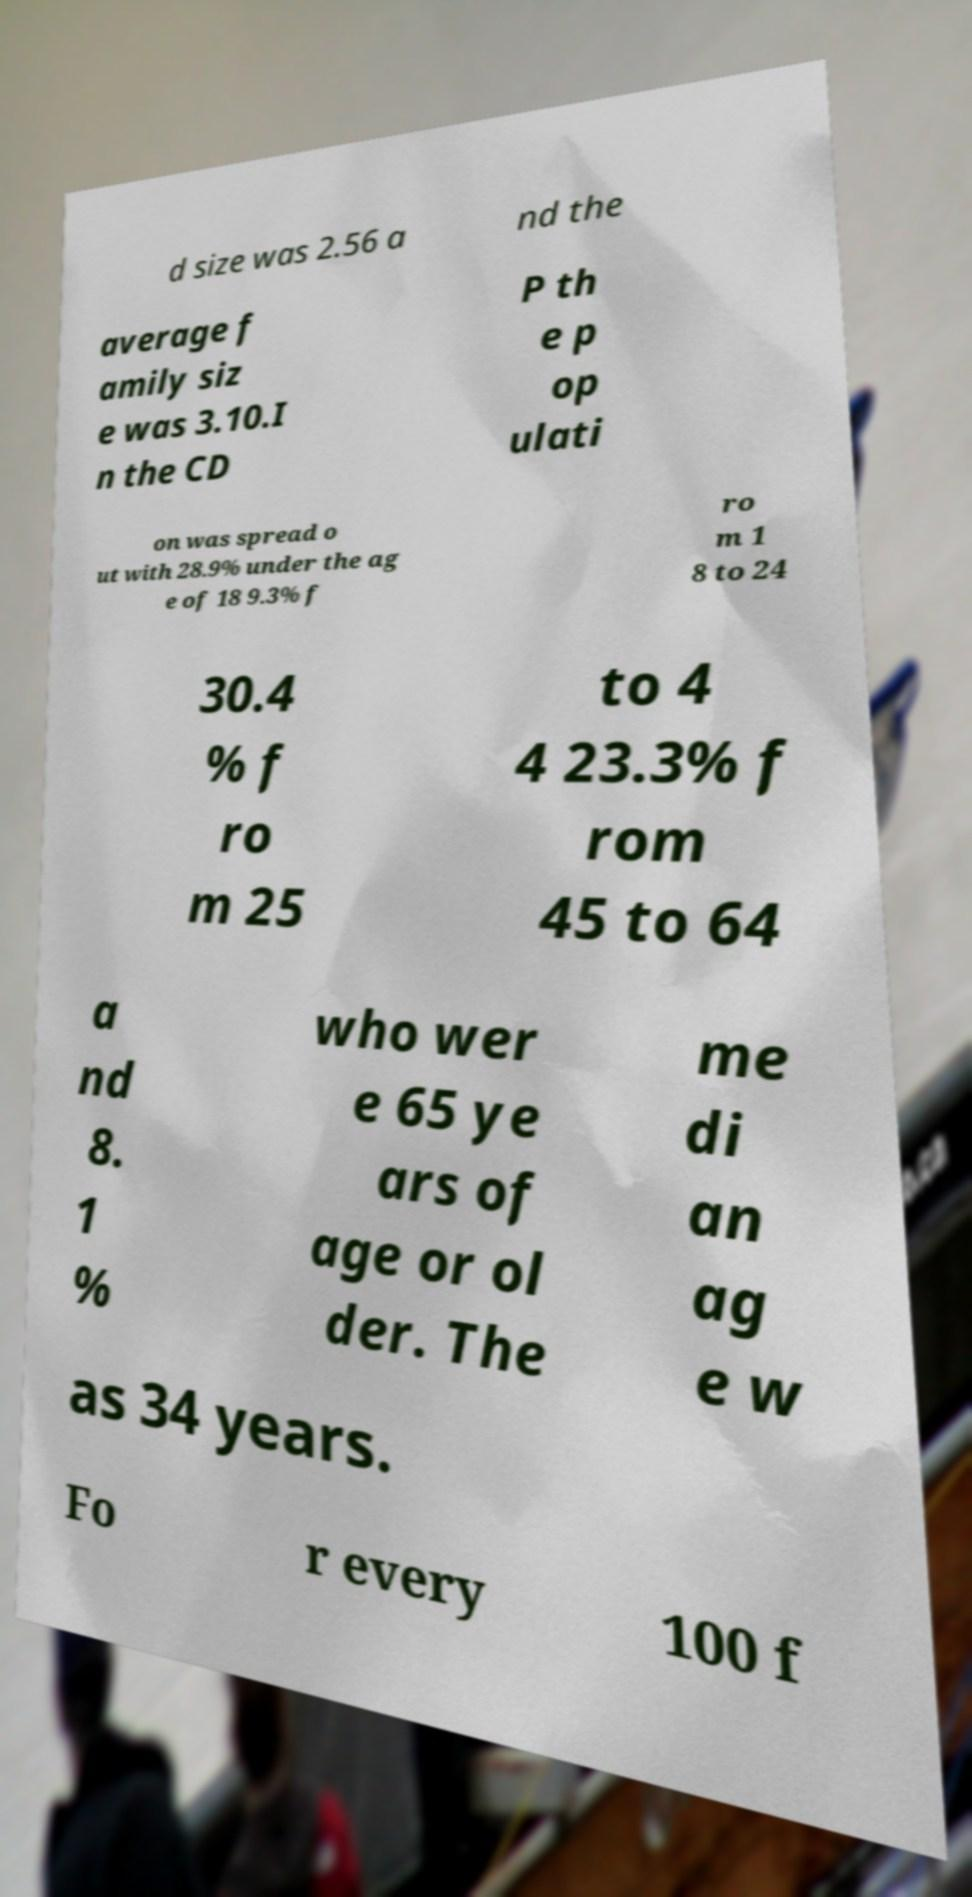Can you read and provide the text displayed in the image?This photo seems to have some interesting text. Can you extract and type it out for me? d size was 2.56 a nd the average f amily siz e was 3.10.I n the CD P th e p op ulati on was spread o ut with 28.9% under the ag e of 18 9.3% f ro m 1 8 to 24 30.4 % f ro m 25 to 4 4 23.3% f rom 45 to 64 a nd 8. 1 % who wer e 65 ye ars of age or ol der. The me di an ag e w as 34 years. Fo r every 100 f 